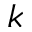Convert formula to latex. <formula><loc_0><loc_0><loc_500><loc_500>k</formula> 